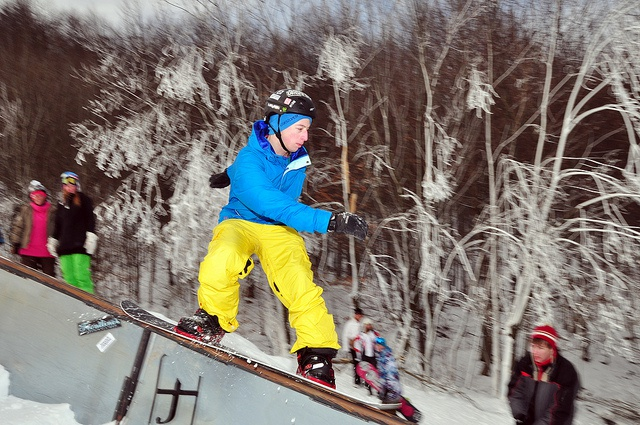Describe the objects in this image and their specific colors. I can see people in lightgray, lightblue, yellow, gold, and black tones, people in lightgray, black, maroon, and brown tones, people in lightgray, black, green, and darkgray tones, people in lightgray, black, brown, and maroon tones, and snowboard in lightgray, gray, darkgray, and black tones in this image. 